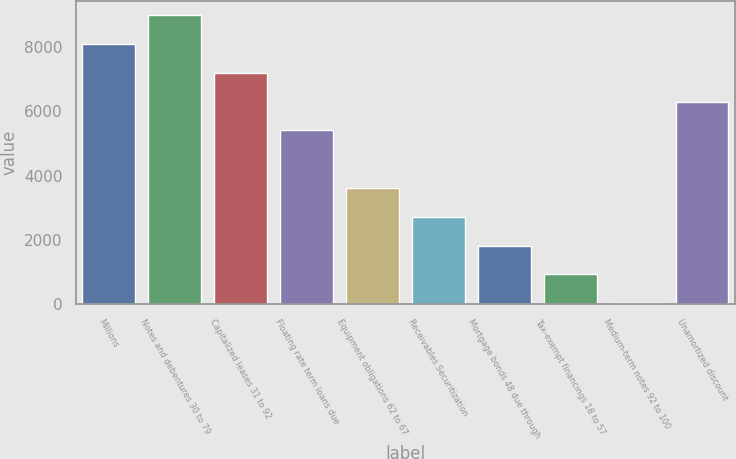<chart> <loc_0><loc_0><loc_500><loc_500><bar_chart><fcel>Millions<fcel>Notes and debentures 30 to 79<fcel>Capitalized leases 31 to 92<fcel>Floating rate term loans due<fcel>Equipment obligations 62 to 67<fcel>Receivables Securitization<fcel>Mortgage bonds 48 due through<fcel>Tax-exempt financings 18 to 57<fcel>Medium-term notes 92 to 100<fcel>Unamortized discount<nl><fcel>8100.5<fcel>8997<fcel>7204<fcel>5411<fcel>3618<fcel>2721.5<fcel>1825<fcel>928.5<fcel>32<fcel>6307.5<nl></chart> 